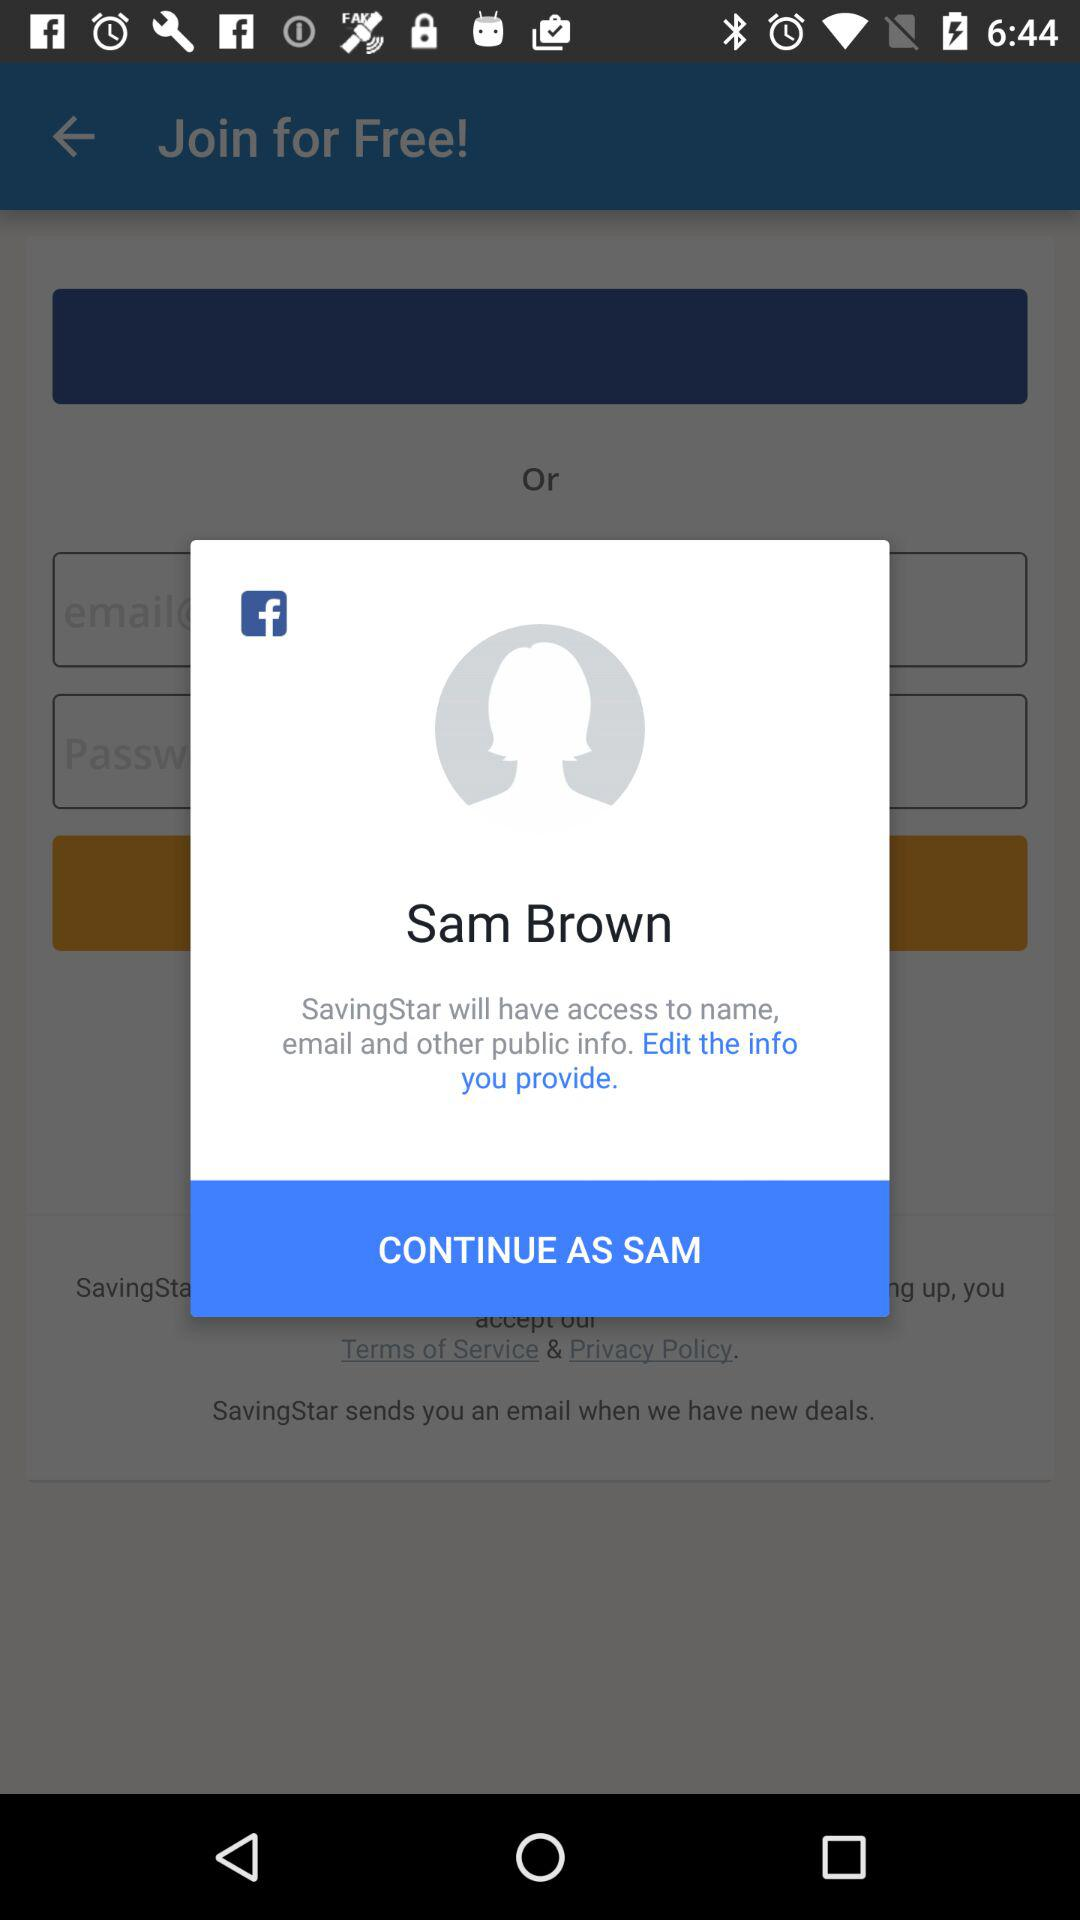What is the name of the person? The name of the person is Sam Brown. 